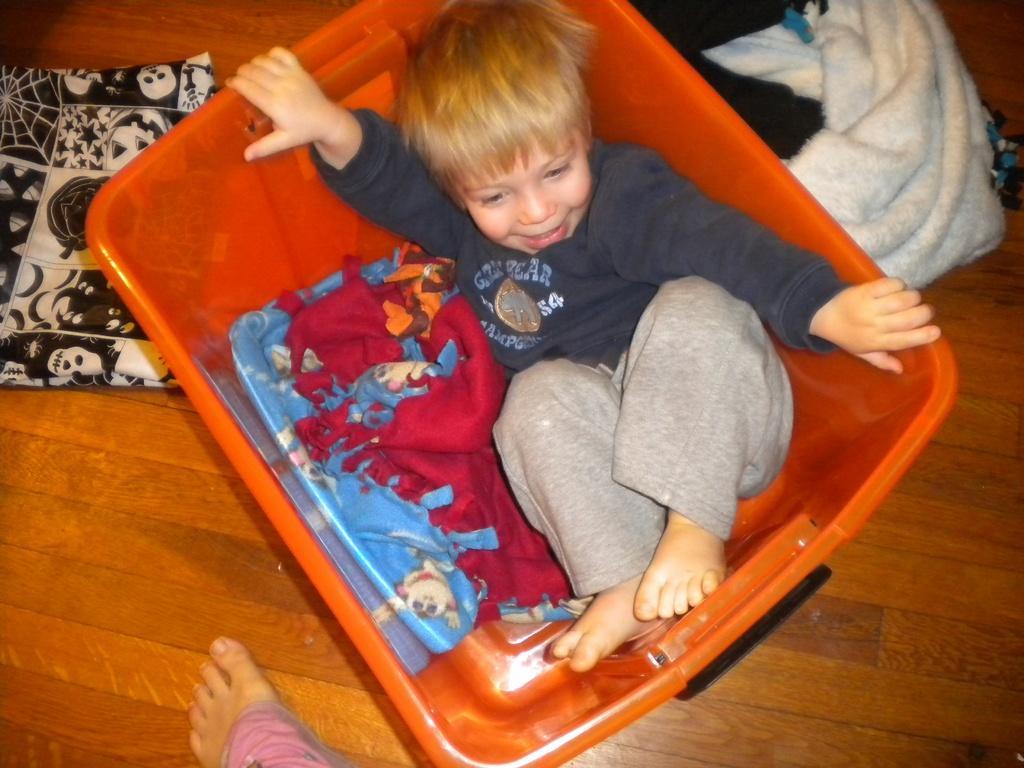In one or two sentences, can you explain what this image depicts? This picture shows a boy in the basket and we see few clothes on the floor and a cloth in the basket and we see a human leg 